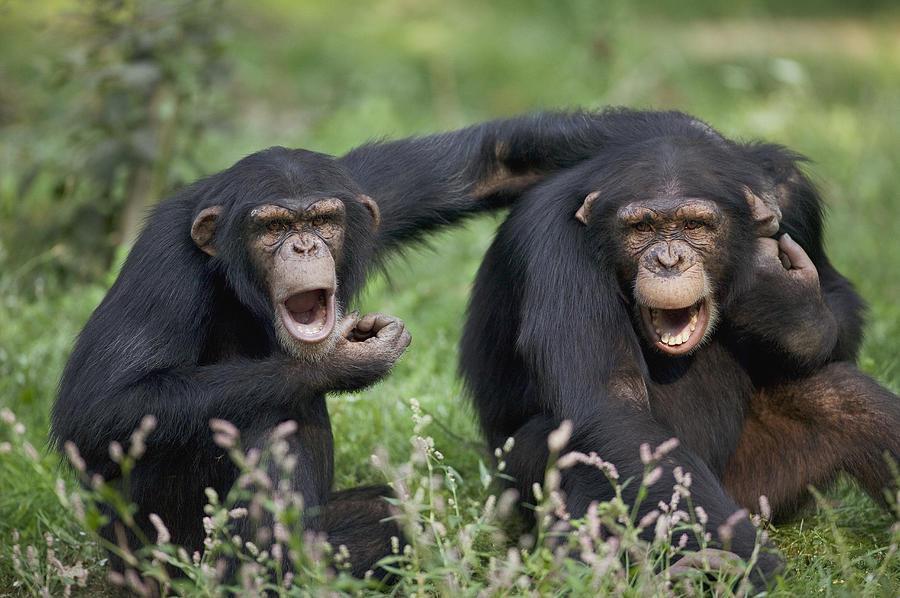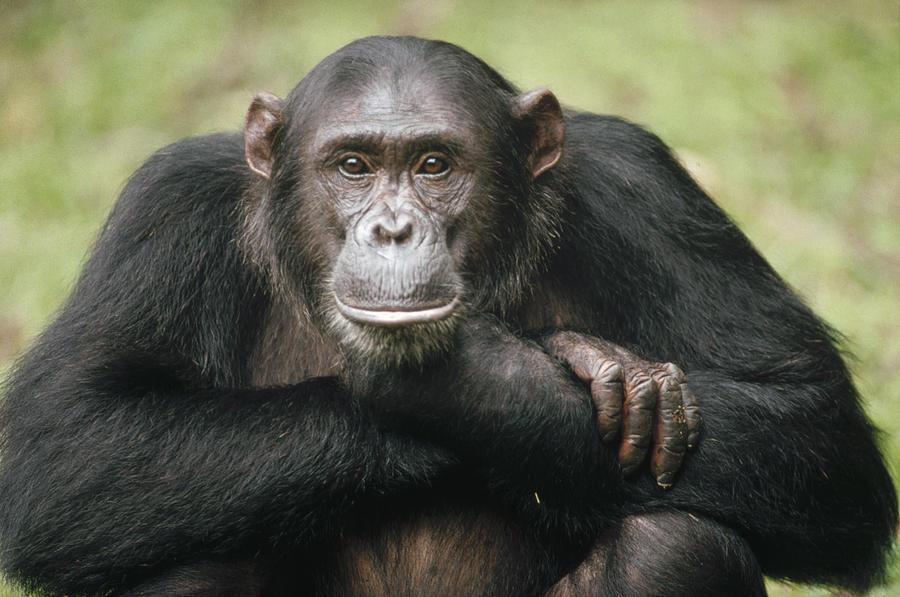The first image is the image on the left, the second image is the image on the right. Given the left and right images, does the statement "The young woman is pointing towards her eye, teaching sign language to a chimp with a heart on it's white shirt." hold true? Answer yes or no. No. The first image is the image on the left, the second image is the image on the right. Given the left and right images, does the statement "There is a color photograph of a woman signing to a chimpanzee." hold true? Answer yes or no. No. The first image is the image on the left, the second image is the image on the right. For the images displayed, is the sentence "There's exactly two chimpanzees." factually correct? Answer yes or no. No. 